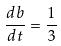<formula> <loc_0><loc_0><loc_500><loc_500>\frac { d b } { d t } = \frac { 1 } { 3 }</formula> 